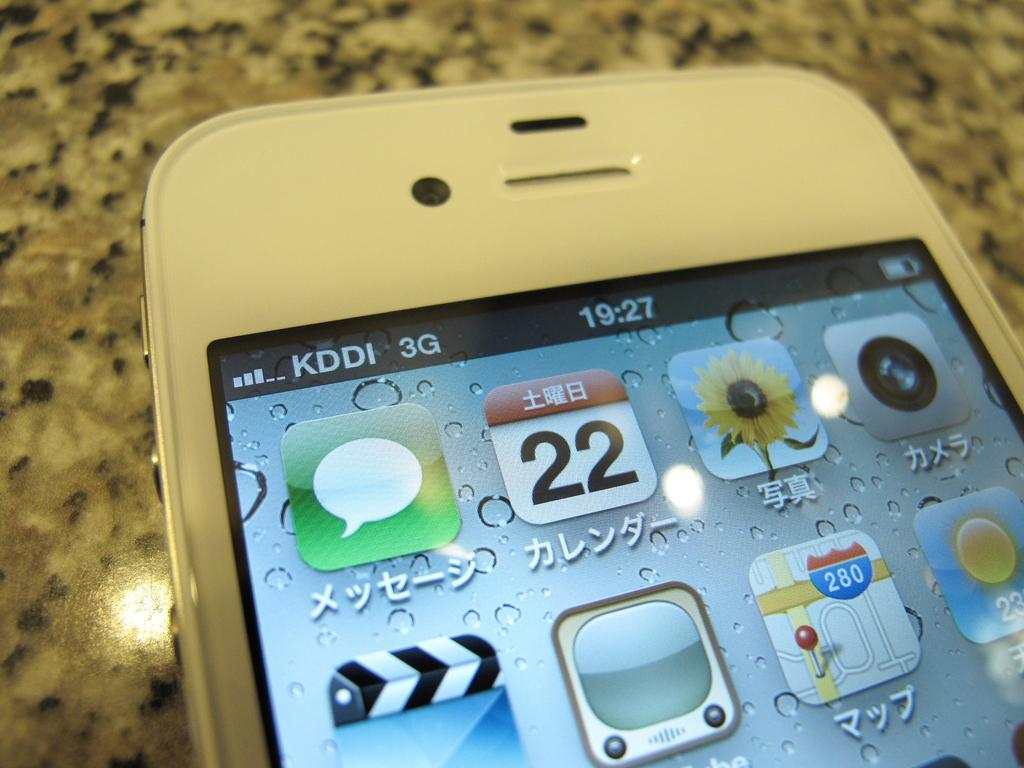<image>
Present a compact description of the photo's key features. A smart phone that runs on KDDI 3G showing it si 19:27. 